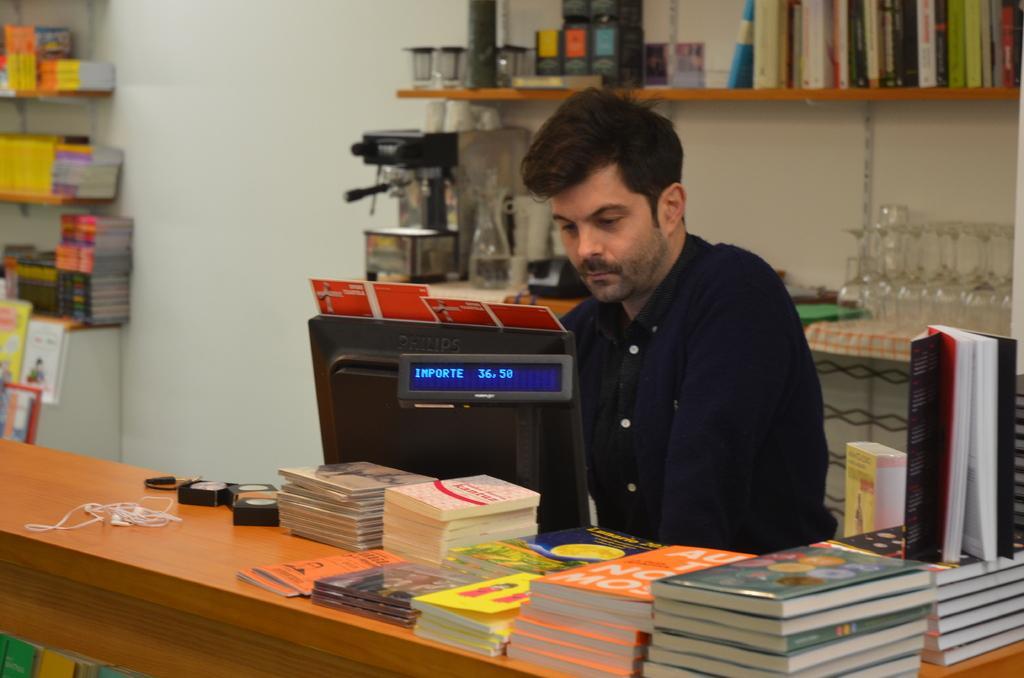Please provide a concise description of this image. In this picture, There is a table which is in yellow color on that table there are some books and there is a computer which is in black color and in the middle there is a man sitting and he is looking in the computer, In the background there are some books kept in the shelf and there are some glasses kept on the table. 